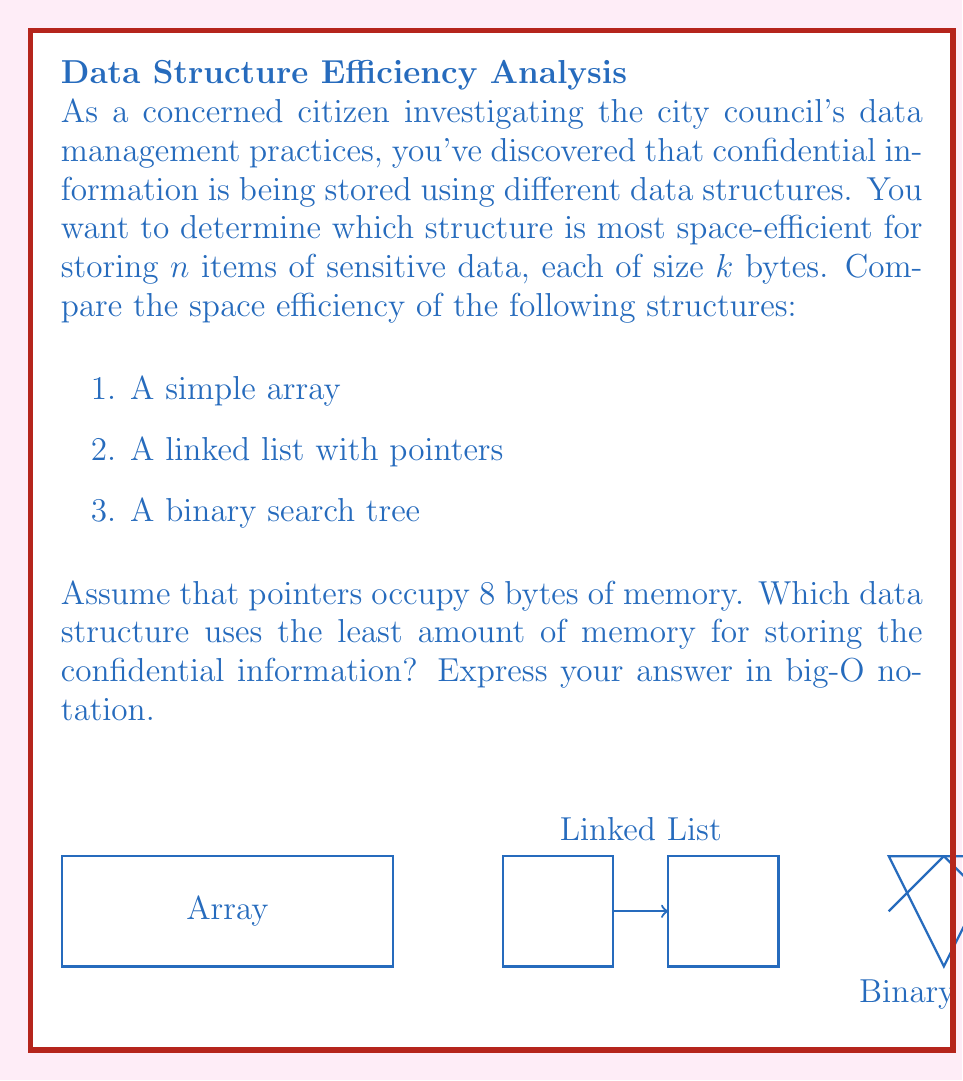Can you answer this question? Let's analyze the space efficiency of each data structure:

1. Simple Array:
   - Space required = $n * k$ bytes
   - Big-O notation: $O(n)$

2. Linked List with pointers:
   - Each node contains the data ($k$ bytes) and a pointer to the next node (8 bytes)
   - Space required = $n * (k + 8)$ bytes
   - Big-O notation: $O(n)$

3. Binary Search Tree:
   - Each node contains the data ($k$ bytes) and two pointers (left and right child, 16 bytes total)
   - Space required = $n * (k + 16)$ bytes
   - Big-O notation: $O(n)$

All three data structures have a linear space complexity of $O(n)$. However, the constant factors differ:

- Array: $n * k$
- Linked List: $n * (k + 8)$
- Binary Search Tree: $n * (k + 16)$

The array uses the least amount of memory as it doesn't require additional space for pointers. The linked list uses slightly more due to the single pointer per node, and the binary search tree uses the most due to two pointers per node.

Therefore, the simple array is the most space-efficient structure for storing the confidential information.
Answer: $O(n)$, with the array being the most efficient 